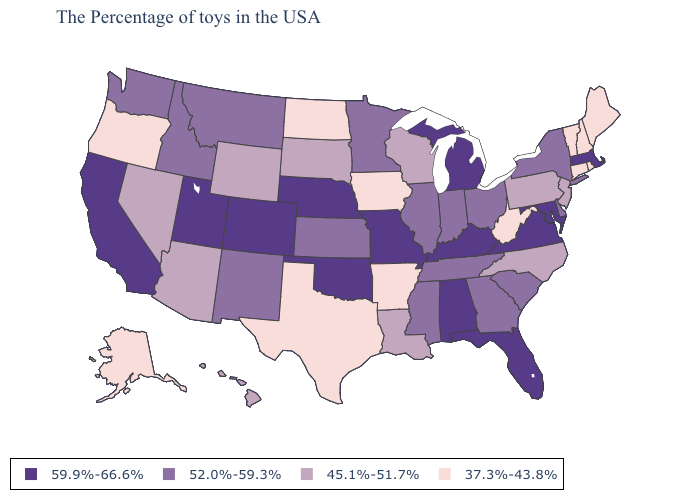Does Michigan have the highest value in the USA?
Be succinct. Yes. Name the states that have a value in the range 45.1%-51.7%?
Quick response, please. New Jersey, Pennsylvania, North Carolina, Wisconsin, Louisiana, South Dakota, Wyoming, Arizona, Nevada, Hawaii. How many symbols are there in the legend?
Short answer required. 4. Does Michigan have the lowest value in the USA?
Answer briefly. No. What is the value of Vermont?
Keep it brief. 37.3%-43.8%. Is the legend a continuous bar?
Concise answer only. No. Name the states that have a value in the range 45.1%-51.7%?
Keep it brief. New Jersey, Pennsylvania, North Carolina, Wisconsin, Louisiana, South Dakota, Wyoming, Arizona, Nevada, Hawaii. Name the states that have a value in the range 59.9%-66.6%?
Quick response, please. Massachusetts, Maryland, Virginia, Florida, Michigan, Kentucky, Alabama, Missouri, Nebraska, Oklahoma, Colorado, Utah, California. Name the states that have a value in the range 45.1%-51.7%?
Be succinct. New Jersey, Pennsylvania, North Carolina, Wisconsin, Louisiana, South Dakota, Wyoming, Arizona, Nevada, Hawaii. What is the value of Louisiana?
Keep it brief. 45.1%-51.7%. Name the states that have a value in the range 37.3%-43.8%?
Quick response, please. Maine, Rhode Island, New Hampshire, Vermont, Connecticut, West Virginia, Arkansas, Iowa, Texas, North Dakota, Oregon, Alaska. Among the states that border Maryland , does Delaware have the lowest value?
Quick response, please. No. Does Wisconsin have the highest value in the USA?
Write a very short answer. No. Which states hav the highest value in the South?
Be succinct. Maryland, Virginia, Florida, Kentucky, Alabama, Oklahoma. What is the value of Oregon?
Keep it brief. 37.3%-43.8%. 